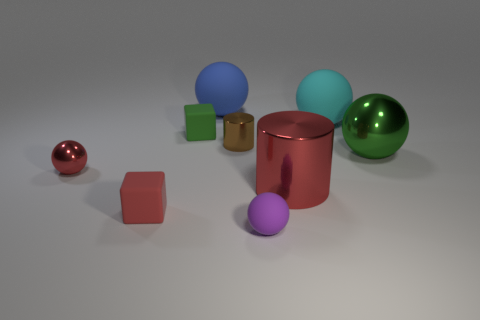Subtract 2 spheres. How many spheres are left? 3 Subtract all small red spheres. How many spheres are left? 4 Subtract all purple balls. How many balls are left? 4 Subtract all yellow spheres. Subtract all red cubes. How many spheres are left? 5 Add 1 large purple metal cubes. How many objects exist? 10 Subtract all cylinders. How many objects are left? 7 Subtract 0 cyan blocks. How many objects are left? 9 Subtract all tiny green objects. Subtract all yellow objects. How many objects are left? 8 Add 6 tiny matte objects. How many tiny matte objects are left? 9 Add 5 big red metallic cylinders. How many big red metallic cylinders exist? 6 